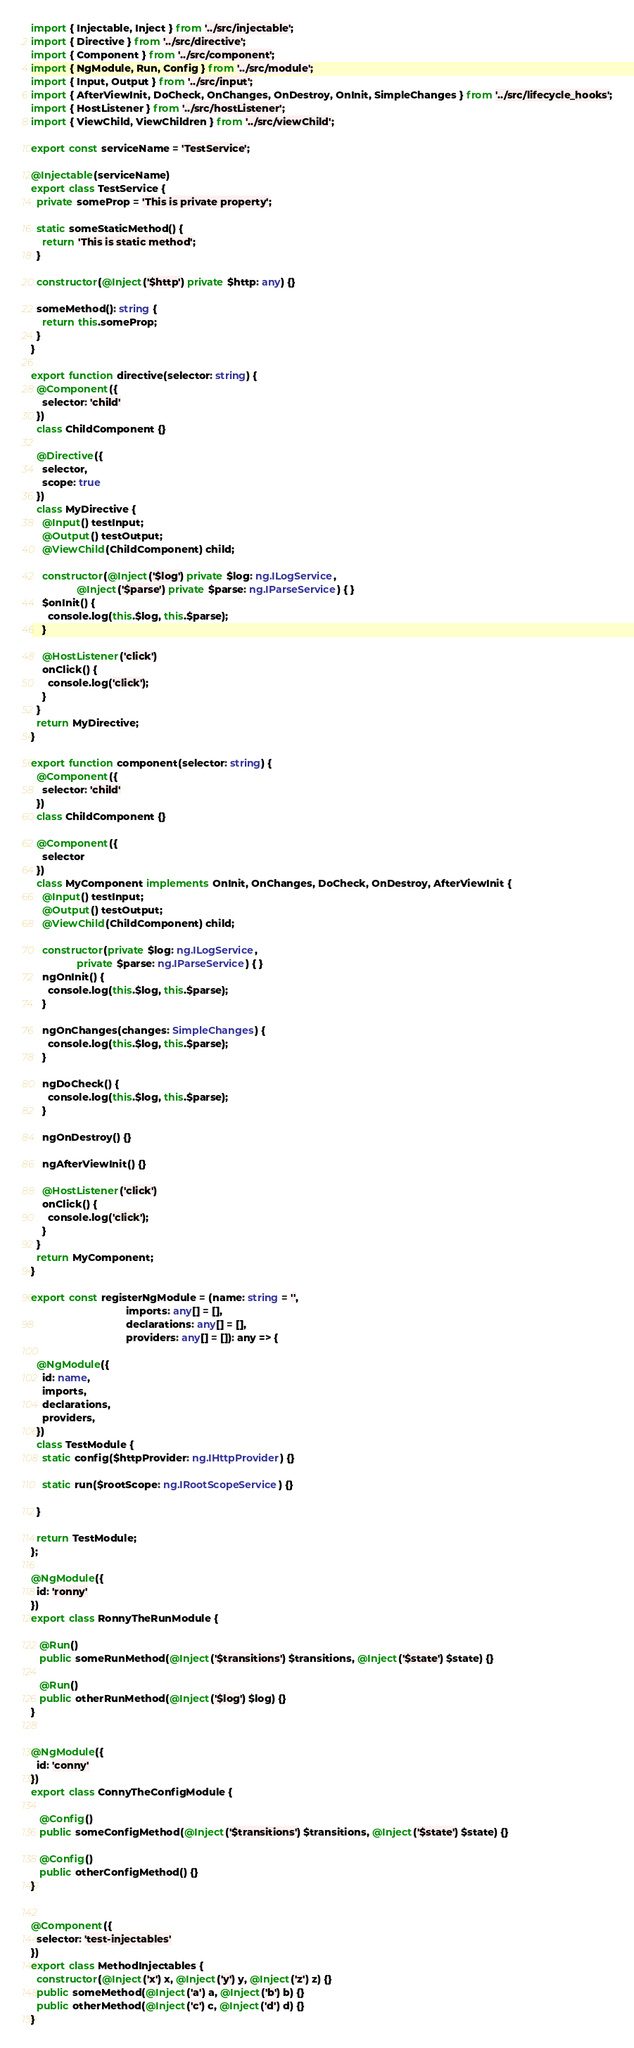Convert code to text. <code><loc_0><loc_0><loc_500><loc_500><_TypeScript_>import { Injectable, Inject } from '../src/injectable';
import { Directive } from '../src/directive';
import { Component } from '../src/component';
import { NgModule, Run, Config } from '../src/module';
import { Input, Output } from '../src/input';
import { AfterViewInit, DoCheck, OnChanges, OnDestroy, OnInit, SimpleChanges } from '../src/lifecycle_hooks';
import { HostListener } from '../src/hostListener';
import { ViewChild, ViewChildren } from '../src/viewChild';

export const serviceName = 'TestService';

@Injectable(serviceName)
export class TestService {
  private someProp = 'This is private property';

  static someStaticMethod() {
    return 'This is static method';
  }

  constructor(@Inject('$http') private $http: any) {}

  someMethod(): string {
    return this.someProp;
  }
}

export function directive(selector: string) {
  @Component({
    selector: 'child'
  })
  class ChildComponent {}

  @Directive({
    selector,
    scope: true
  })
  class MyDirective {
    @Input() testInput;
    @Output() testOutput;
    @ViewChild(ChildComponent) child;

    constructor(@Inject('$log') private $log: ng.ILogService,
                @Inject('$parse') private $parse: ng.IParseService) { }
    $onInit() {
      console.log(this.$log, this.$parse);
    }

    @HostListener('click')
    onClick() {
      console.log('click');
    }
  }
  return MyDirective;
}

export function component(selector: string) {
  @Component({
    selector: 'child'
  })
  class ChildComponent {}

  @Component({
    selector
  })
  class MyComponent implements OnInit, OnChanges, DoCheck, OnDestroy, AfterViewInit {
    @Input() testInput;
    @Output() testOutput;
    @ViewChild(ChildComponent) child;

    constructor(private $log: ng.ILogService,
                private $parse: ng.IParseService) { }
    ngOnInit() {
      console.log(this.$log, this.$parse);
    }

    ngOnChanges(changes: SimpleChanges) {
      console.log(this.$log, this.$parse);
    }

    ngDoCheck() {
      console.log(this.$log, this.$parse);
    }

    ngOnDestroy() {}

    ngAfterViewInit() {}

    @HostListener('click')
    onClick() {
      console.log('click');
    }
  }
  return MyComponent;
}

export const registerNgModule = (name: string = '',
                                 imports: any[] = [],
                                 declarations: any[] = [],
                                 providers: any[] = []): any => {

  @NgModule({
    id: name,
    imports,
    declarations,
    providers,
  })
  class TestModule {
    static config($httpProvider: ng.IHttpProvider) {}

    static run($rootScope: ng.IRootScopeService) {}

  }

  return TestModule;
};

@NgModule({
  id: 'ronny'
})
export class RonnyTheRunModule {

   @Run()
   public someRunMethod(@Inject('$transitions') $transitions, @Inject('$state') $state) {}

   @Run()
   public otherRunMethod(@Inject('$log') $log) {}
}


@NgModule({
  id: 'conny'
})
export class ConnyTheConfigModule {

   @Config()
   public someConfigMethod(@Inject('$transitions') $transitions, @Inject('$state') $state) {}

   @Config()
   public otherConfigMethod() {}
}


@Component({
  selector: 'test-injectables'
})
export class MethodInjectables {
  constructor(@Inject('x') x, @Inject('y') y, @Inject('z') z) {}
  public someMethod(@Inject('a') a, @Inject('b') b) {}
  public otherMethod(@Inject('c') c, @Inject('d') d) {}
}</code> 